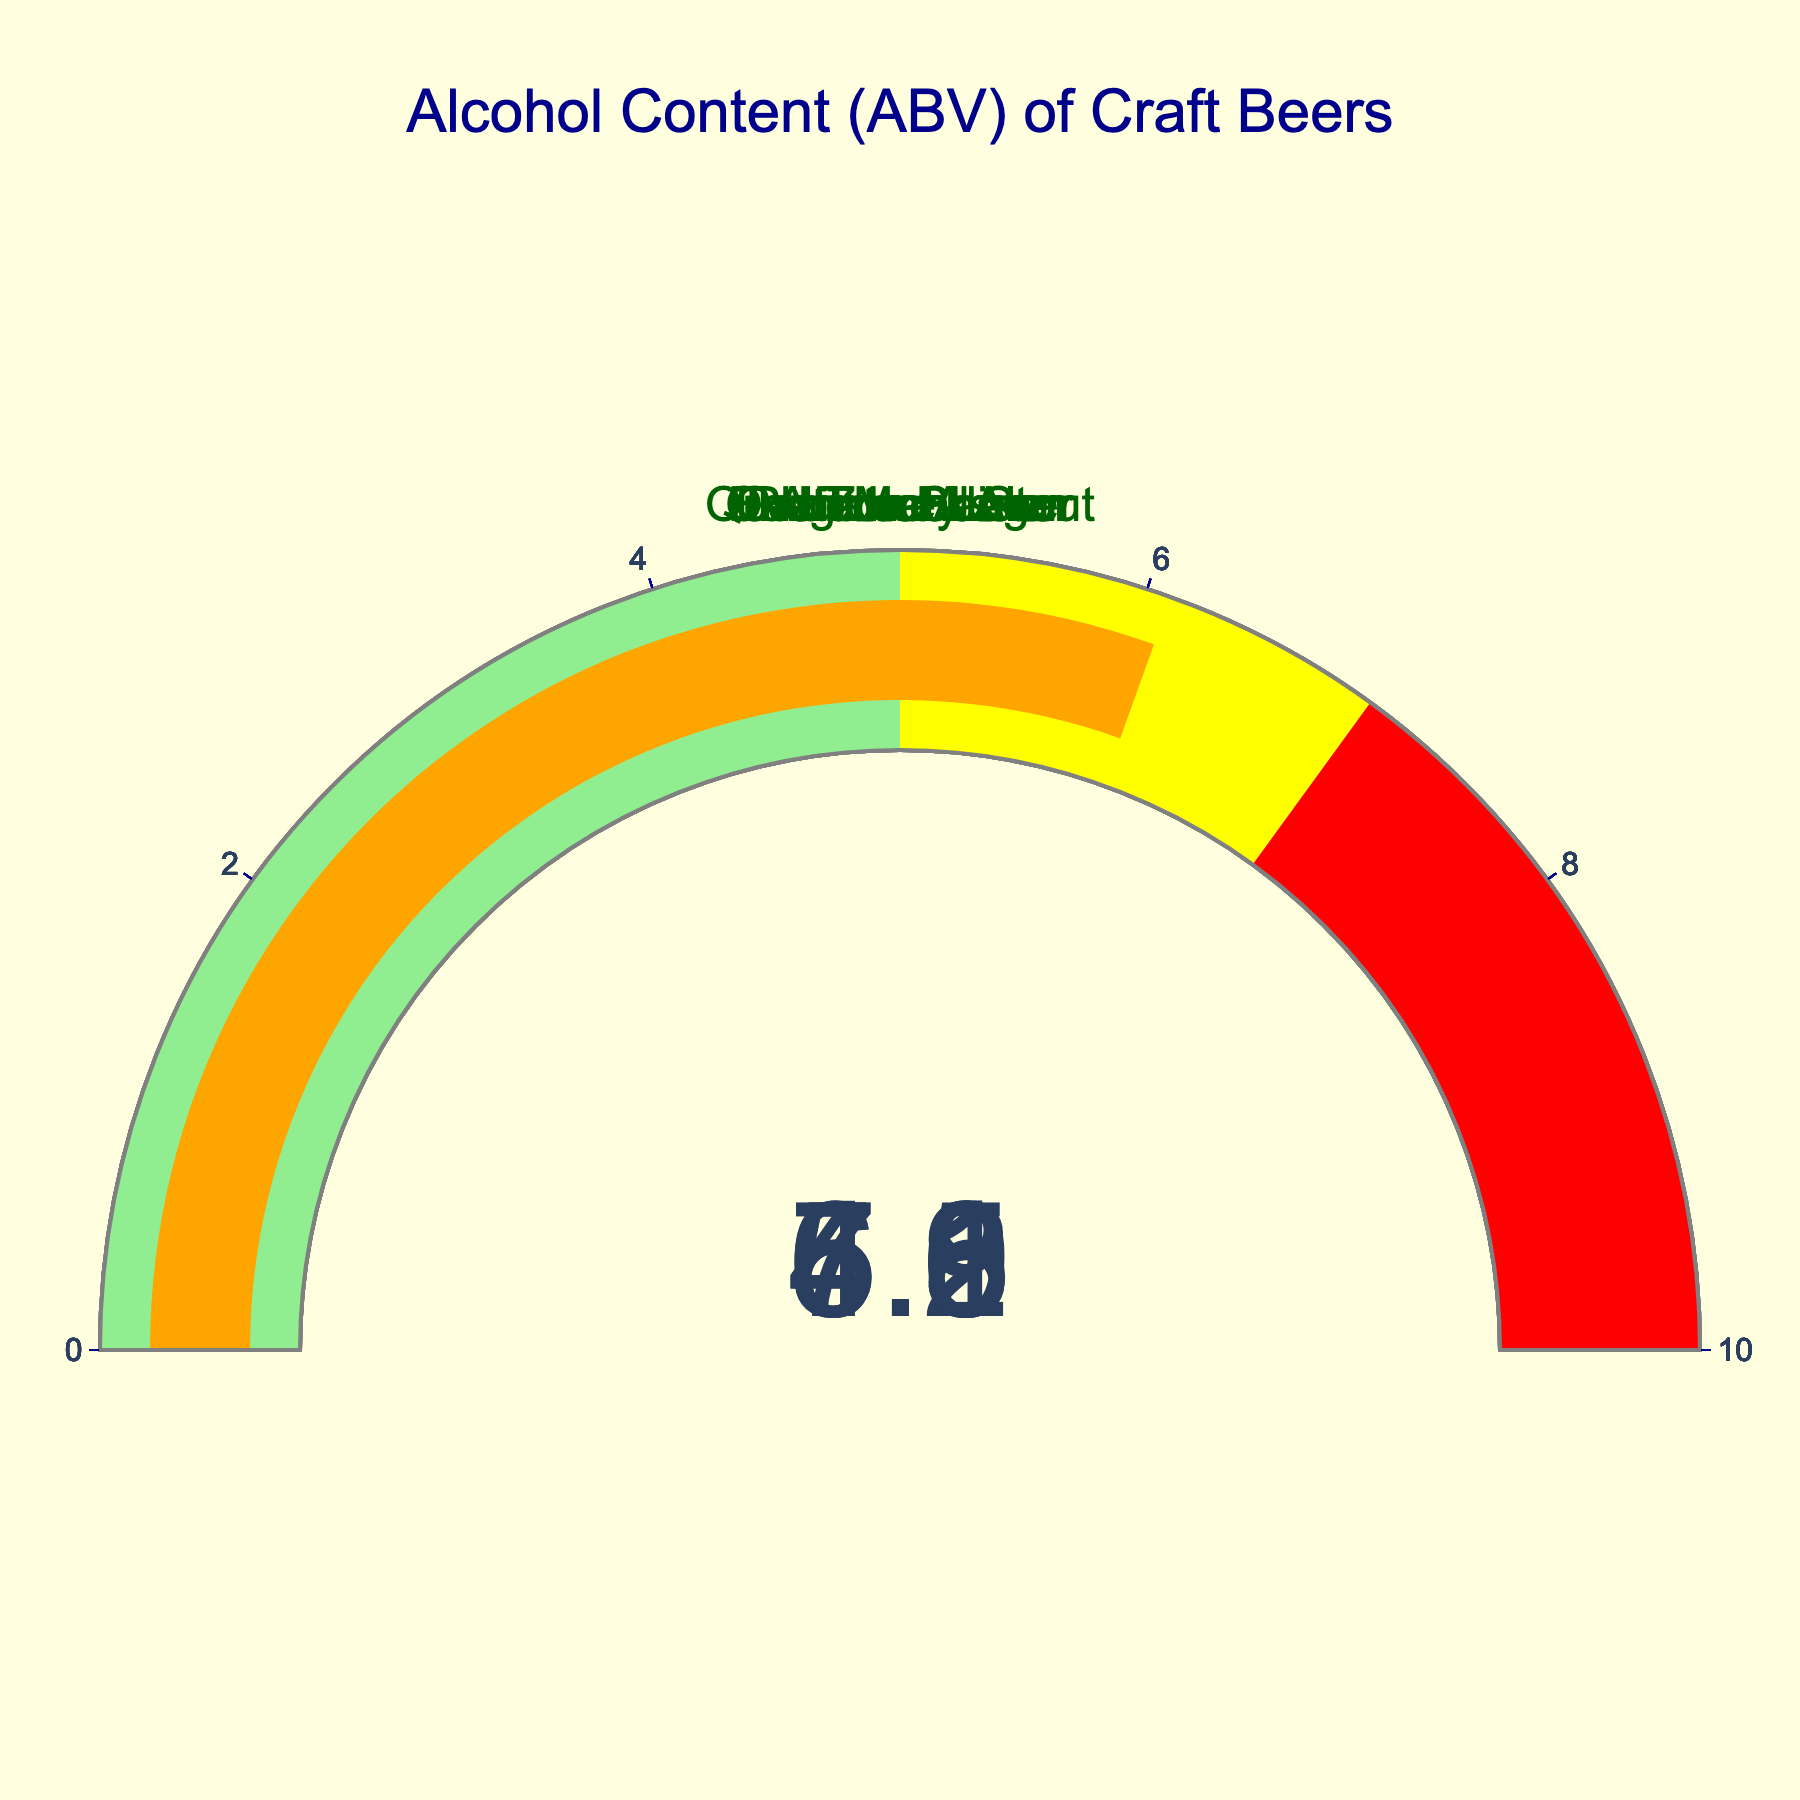what is the alcohol content of Tailgate Pilsner? The gauge chart for each beer shows its alcohol content (ABV). For Tailgate Pilsner, it is highlighted by the gauge.
Answer: 4.3 What range of alcohol content (ABV) is displayed in the figure? The gauges display values between 4.3 and 7.2.
Answer: 4.3 to 7.2 How many craft beers have an alcohol content above 6%? The beers with ABV above 6% are IPA Touchdown (6.5), Quarterback Stout (7.2), and Gridiron Saison (6.1). Count them.
Answer: 3 Which beer has the lowest alcohol content? Compare the values on each gauge. The lowest ABV shown is for Tailgate Pilsner (4.3).
Answer: Tailgate Pilsner What’s the average alcohol content (ABV) of all the beers combined? Add the ABV values for each beer (6.5 + 7.2 + 4.8 + 5.9 + 4.3 + 5.6 + 6.1) and divide by the number of beers (7): (6.5 + 7.2 + 4.8 + 5.9 + 4.3 + 5.6 + 6.1) / 7.
Answer: 5.8 Which beer has the highest alcohol content? Compare the values on each gauge. The highest ABV is Quarterback Stout (7.2).
Answer: Quarterback Stout What is the median alcohol content (ABV) of the craft beers? Order the ABV values (4.3, 4.8, 5.6, 5.9, 6.1, 6.5, 7.2) and find the middle value. The median ABV is 5.9.
Answer: 5.9 How does the alcohol content of End Zone Lager compare to Gridiron Saison? End Zone Lager has an ABV of 4.8, and Gridiron Saison has an ABV of 6.1. Compare these values.
Answer: End Zone Lager is lower How many beers have an alcohol content labeled in the yellow range (5% to 7%)? Look at the color-coded gauge regions. Five beers fall into the yellow range: IPA Touchdown, Hail Mary Ale, Overtime Amber, and Gridiron Saison.
Answer: 4 What is the difference in alcohol content between Hail Mary Ale and Tailgate Pilsner? Subtract the ABV of Tailgate Pilsner (4.3) from Hail Mary Ale (5.9): 5.9 - 4.3.
Answer: 1.6 